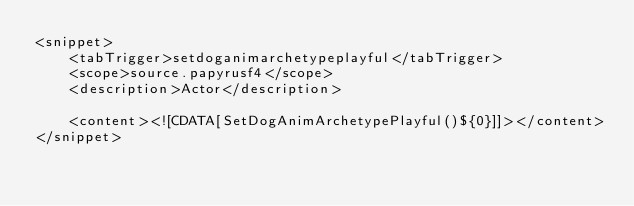<code> <loc_0><loc_0><loc_500><loc_500><_XML_><snippet>
    <tabTrigger>setdoganimarchetypeplayful</tabTrigger>
    <scope>source.papyrusf4</scope>
    <description>Actor</description>

    <content><![CDATA[SetDogAnimArchetypePlayful()${0}]]></content>
</snippet>
</code> 